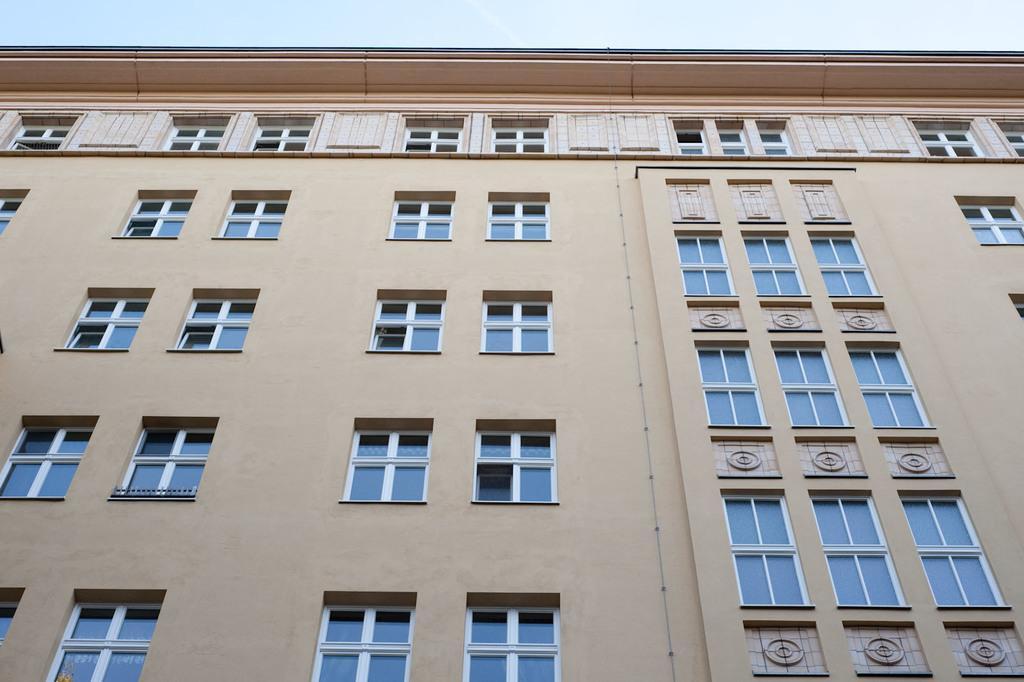Describe this image in one or two sentences. In this picture, we see a building in light grey and light pink color. It has many glass windows. At the top, we see the sky. 